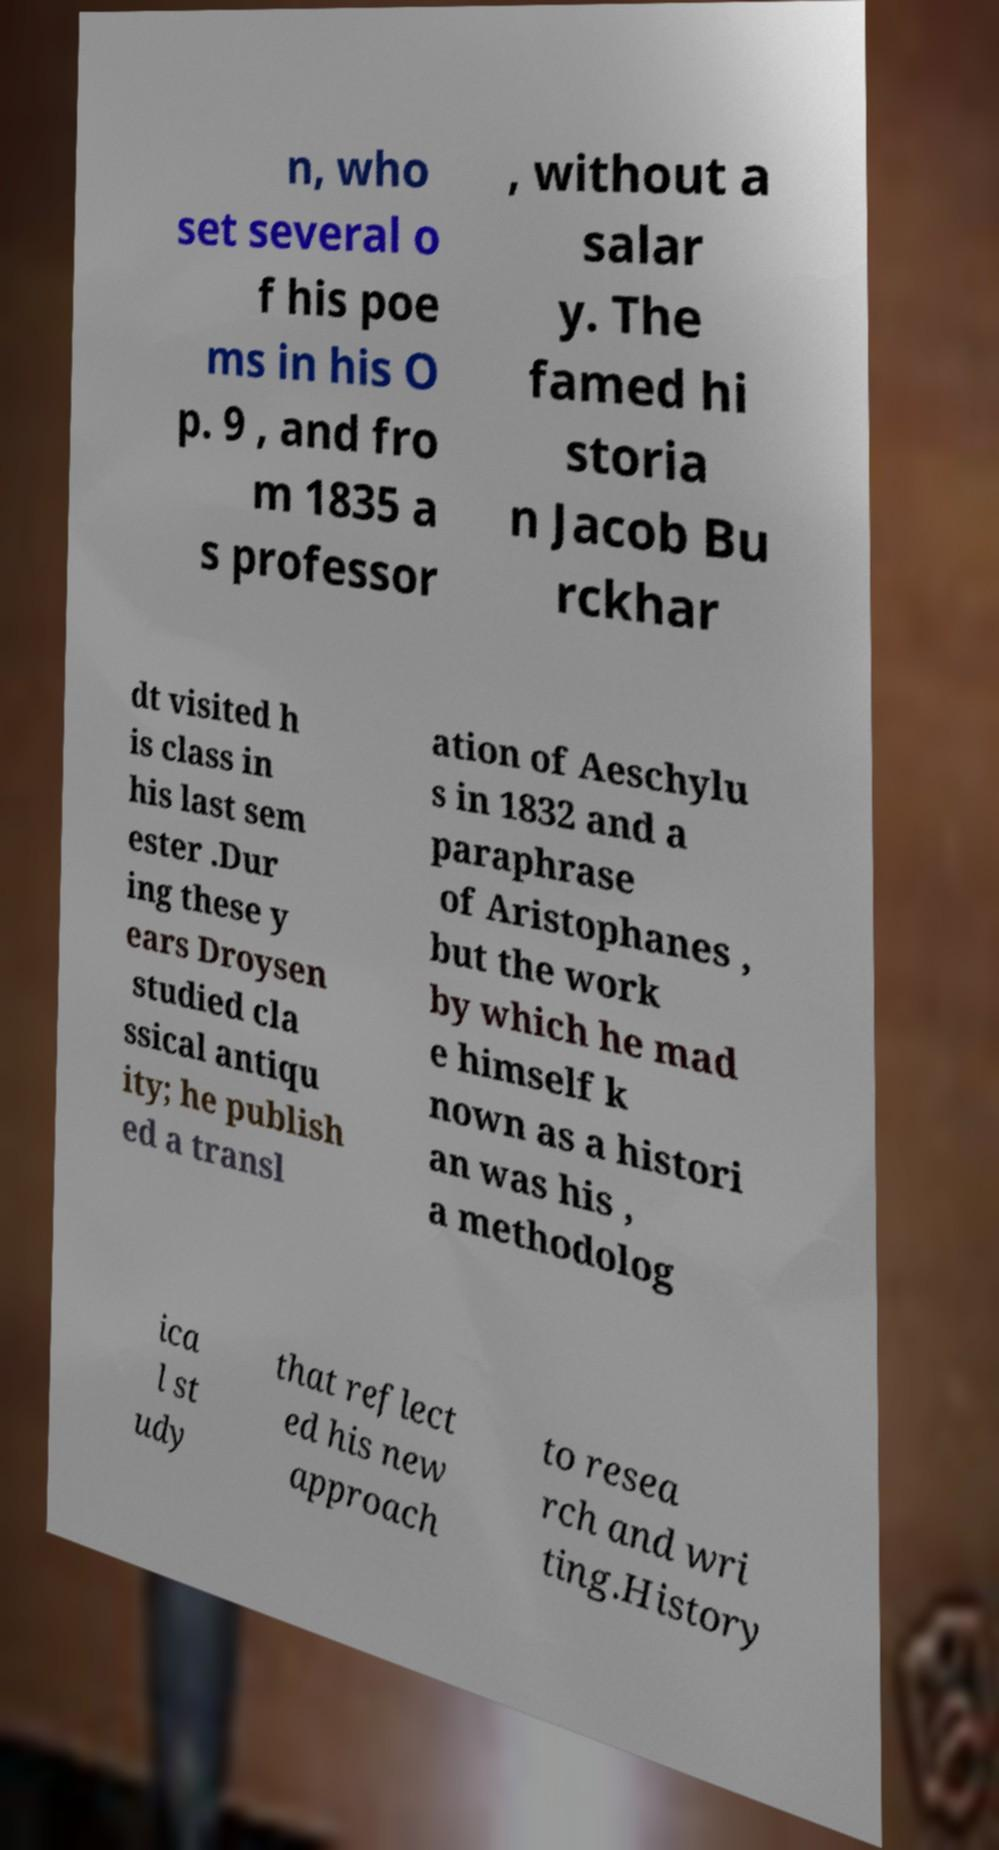Please read and relay the text visible in this image. What does it say? n, who set several o f his poe ms in his O p. 9 , and fro m 1835 a s professor , without a salar y. The famed hi storia n Jacob Bu rckhar dt visited h is class in his last sem ester .Dur ing these y ears Droysen studied cla ssical antiqu ity; he publish ed a transl ation of Aeschylu s in 1832 and a paraphrase of Aristophanes , but the work by which he mad e himself k nown as a histori an was his , a methodolog ica l st udy that reflect ed his new approach to resea rch and wri ting.History 